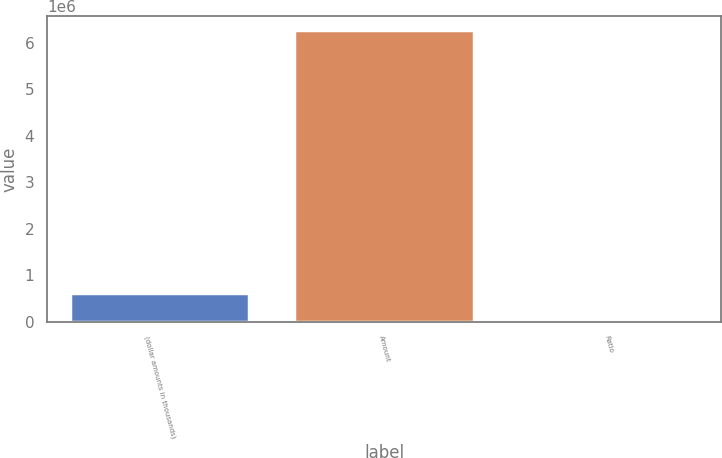Convert chart. <chart><loc_0><loc_0><loc_500><loc_500><bar_chart><fcel>(dollar amounts in thousands)<fcel>Amount<fcel>Ratio<nl><fcel>626599<fcel>6.2659e+06<fcel>9.74<nl></chart> 